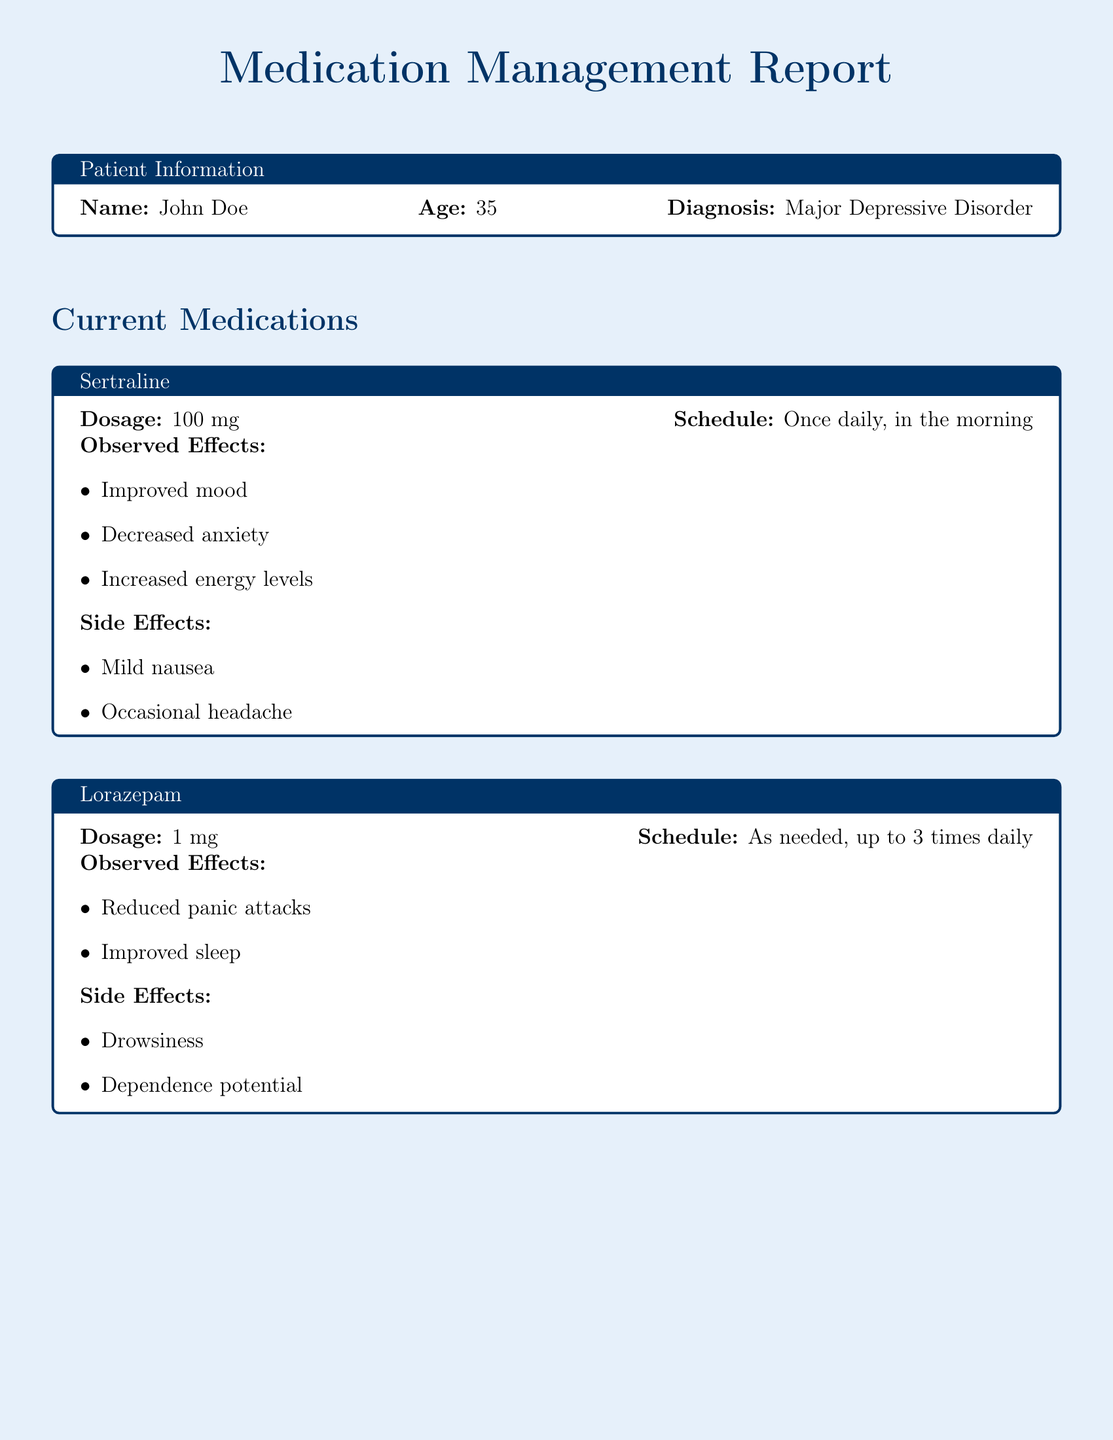What is the patient's name? The patient's name is mentioned at the beginning of the report in the patient information section.
Answer: John Doe What is the diagnosis of the patient? The diagnosis is specified in the patient information section of the report.
Answer: Major Depressive Disorder What is the dosage of Sertraline? The dosage of Sertraline is provided in the medication section under Sertraline.
Answer: 100 mg How often is Lorazepam taken? The schedule for Lorazepam is stated clearly in the medication section for Lorazepam.
Answer: As needed, up to 3 times daily What effects were observed from Sertraline? Observed effects of Sertraline are listed in the medication section specifically under its effects.
Answer: Improved mood, Decreased anxiety, Increased energy levels What side effect is associated with Lorazepam? A side effect of Lorazepam is mentioned in its medication section.
Answer: Drowsiness Who is the psychiatrist mentioned in the report? The psychiatrist's name is included in the psychiatrist input section.
Answer: Dr. Lisa Smith What is the future plan for Sertraline? The future plan for Sertraline is outlined in the psychiatrist input section.
Answer: Continue with Sertraline at the current dosage What additional method is suggested for the patient? Additional notes suggest a method for the patient to help monitor their condition.
Answer: Daily journal What is the follow-up appointment duration? The duration for the follow-up appointment is clearly stated in the psychiatrist input section.
Answer: 4 weeks 